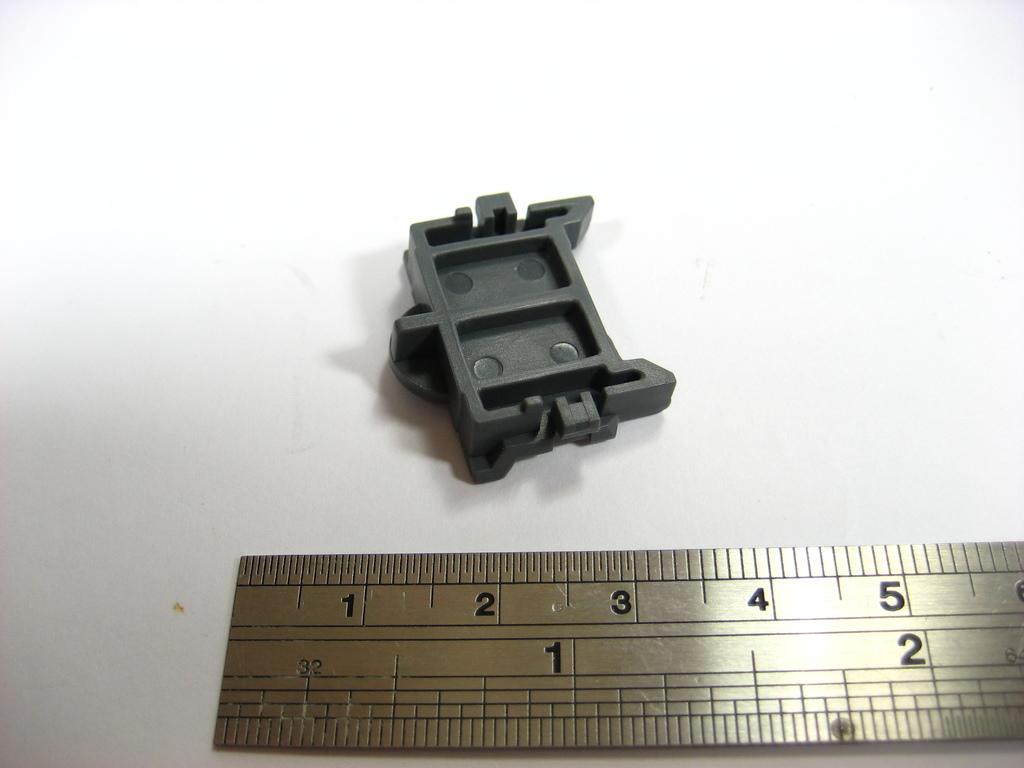What is the biggest number shown on this ruler?
Provide a short and direct response. 5. 